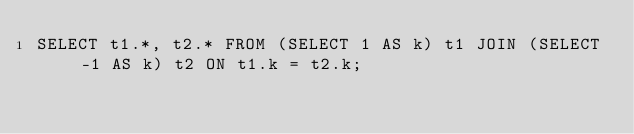Convert code to text. <code><loc_0><loc_0><loc_500><loc_500><_SQL_>SELECT t1.*, t2.* FROM (SELECT 1 AS k) t1 JOIN (SELECT -1 AS k) t2 ON t1.k = t2.k;
</code> 